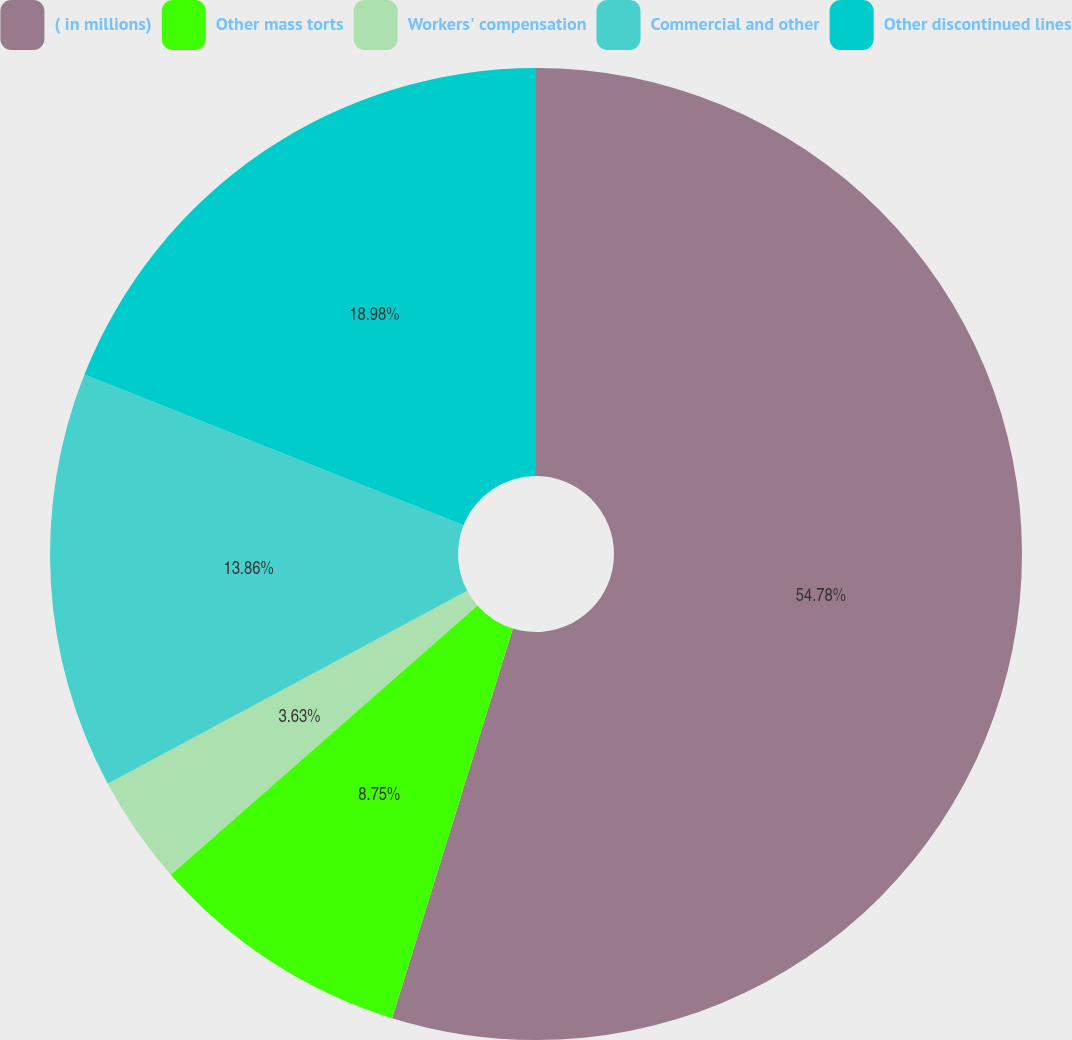<chart> <loc_0><loc_0><loc_500><loc_500><pie_chart><fcel>( in millions)<fcel>Other mass torts<fcel>Workers' compensation<fcel>Commercial and other<fcel>Other discontinued lines<nl><fcel>54.79%<fcel>8.75%<fcel>3.63%<fcel>13.86%<fcel>18.98%<nl></chart> 